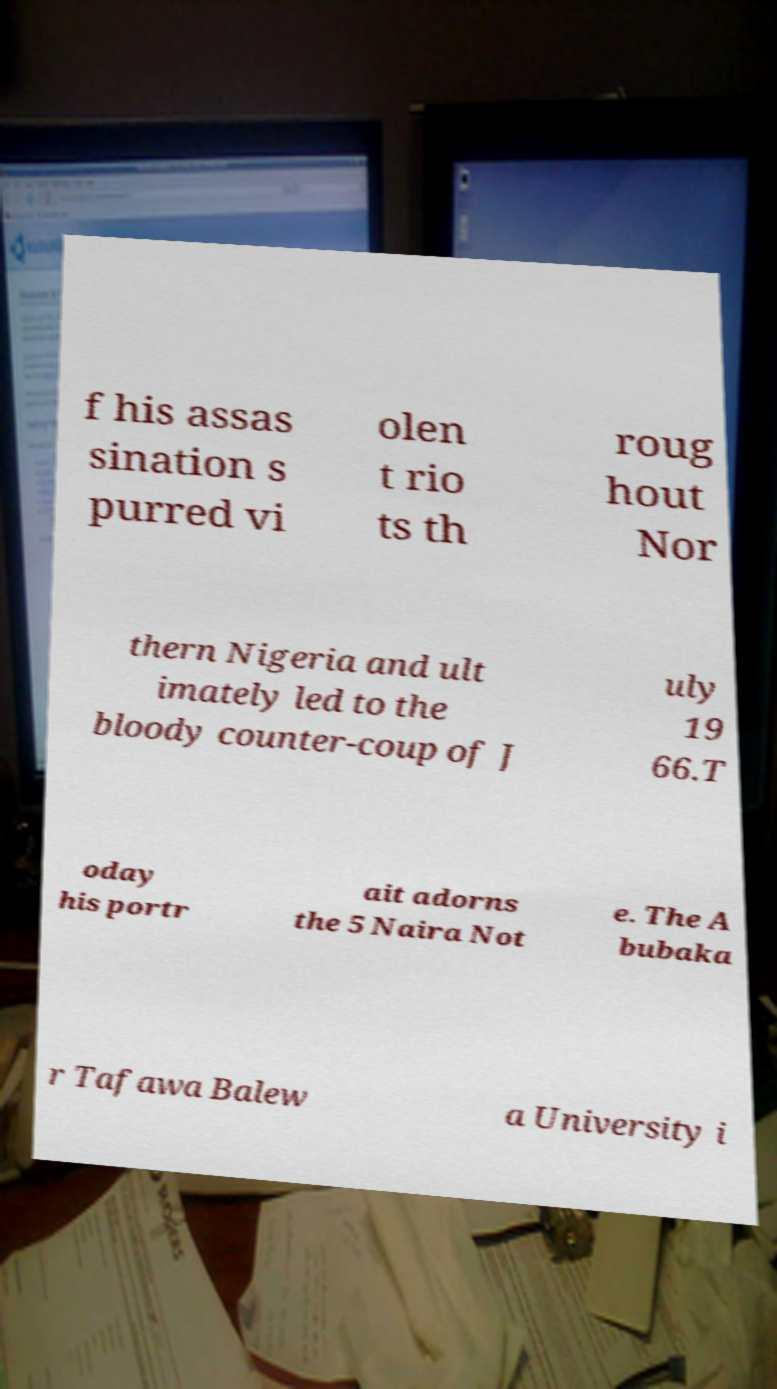I need the written content from this picture converted into text. Can you do that? f his assas sination s purred vi olen t rio ts th roug hout Nor thern Nigeria and ult imately led to the bloody counter-coup of J uly 19 66.T oday his portr ait adorns the 5 Naira Not e. The A bubaka r Tafawa Balew a University i 